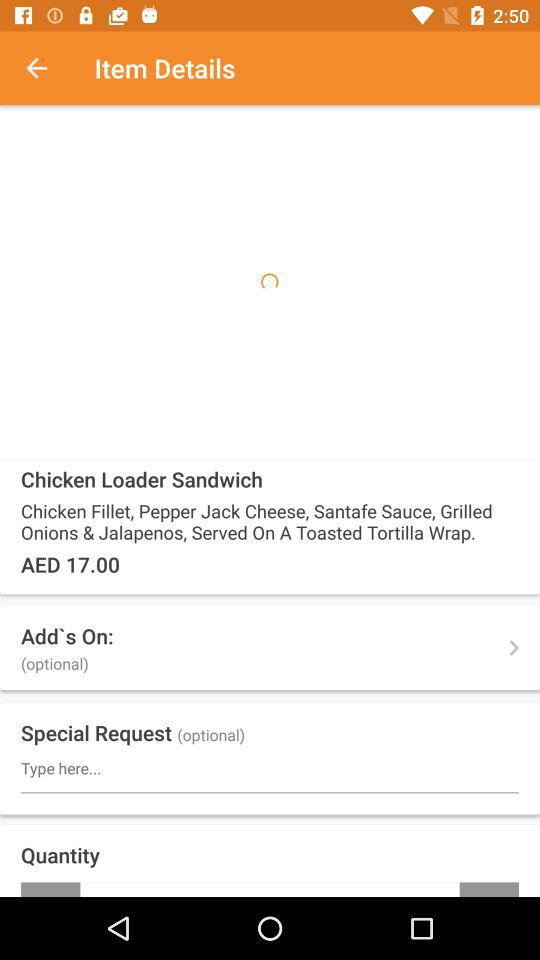What is the dish name? The dish name is "Chicken Loader Sandwich". 